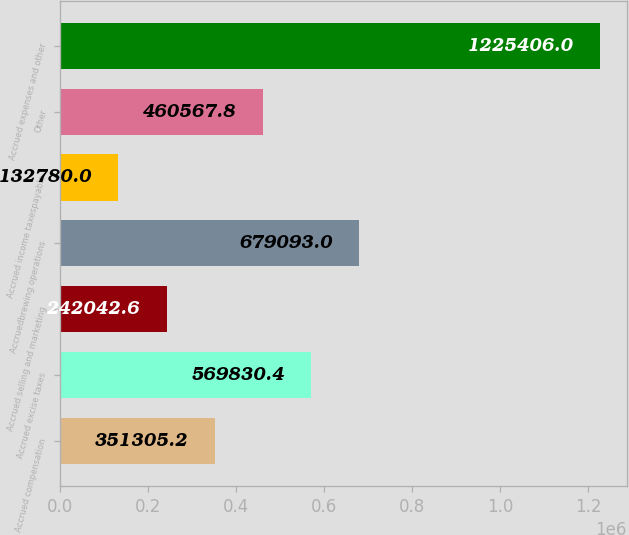Convert chart to OTSL. <chart><loc_0><loc_0><loc_500><loc_500><bar_chart><fcel>Accrued compensation<fcel>Accrued excise taxes<fcel>Accrued selling and marketing<fcel>Accruedbrewing operations<fcel>Accrued income taxespayable<fcel>Other<fcel>Accrued expenses and other<nl><fcel>351305<fcel>569830<fcel>242043<fcel>679093<fcel>132780<fcel>460568<fcel>1.22541e+06<nl></chart> 